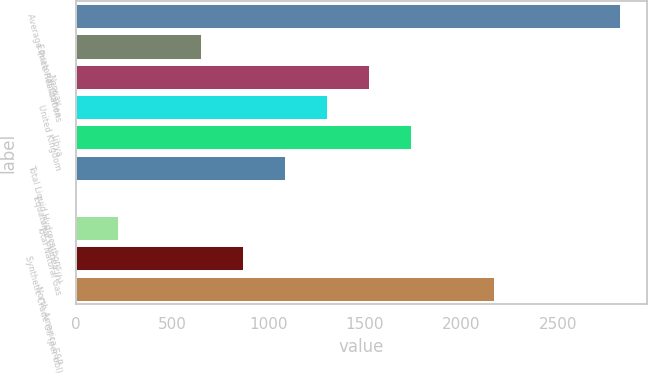Convert chart to OTSL. <chart><loc_0><loc_0><loc_500><loc_500><bar_chart><fcel>Average Price Realizations<fcel>Equatorial Guinea<fcel>Norway<fcel>United Kingdom<fcel>Libya<fcel>Total Liquid Hydrocarbons<fcel>Equatorial Guinea (h)<fcel>Total Natural Gas<fcel>Synthetic Crude Oil (per bbl)<fcel>North America E&P<nl><fcel>2822.28<fcel>651.48<fcel>1519.8<fcel>1302.72<fcel>1736.88<fcel>1085.64<fcel>0.24<fcel>217.32<fcel>868.56<fcel>2171.04<nl></chart> 